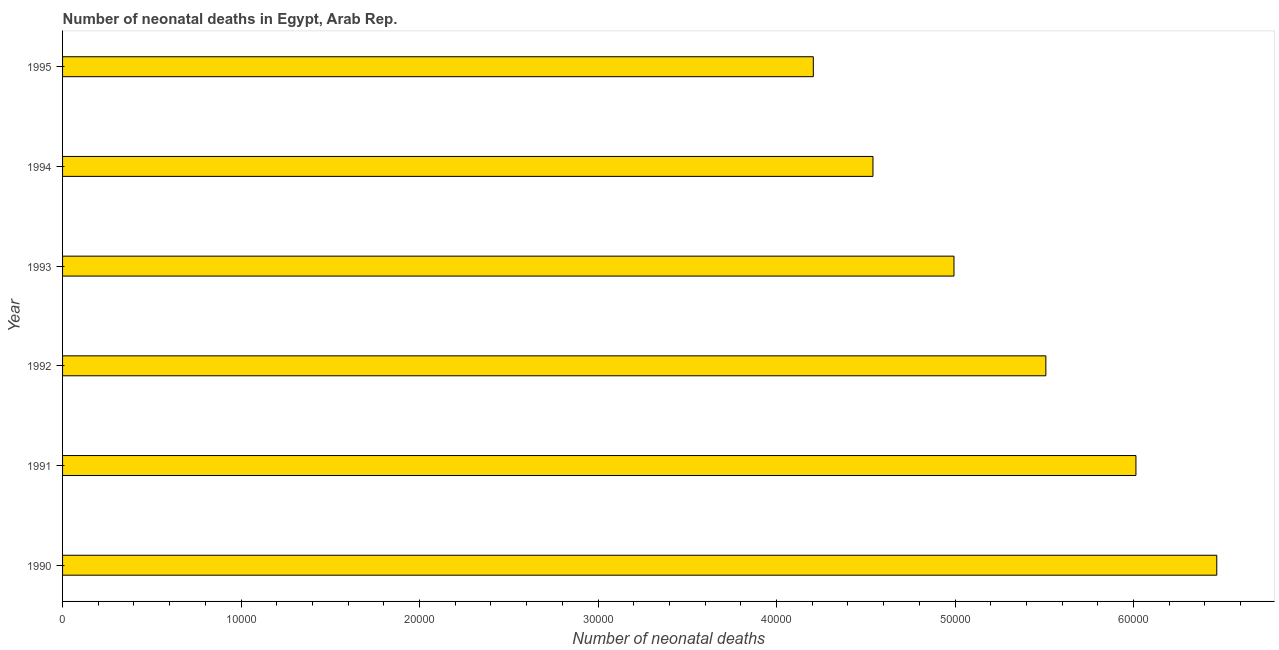Does the graph contain any zero values?
Keep it short and to the point. No. What is the title of the graph?
Offer a very short reply. Number of neonatal deaths in Egypt, Arab Rep. What is the label or title of the X-axis?
Provide a succinct answer. Number of neonatal deaths. What is the number of neonatal deaths in 1991?
Offer a terse response. 6.01e+04. Across all years, what is the maximum number of neonatal deaths?
Provide a succinct answer. 6.47e+04. Across all years, what is the minimum number of neonatal deaths?
Your answer should be very brief. 4.21e+04. What is the sum of the number of neonatal deaths?
Your response must be concise. 3.17e+05. What is the difference between the number of neonatal deaths in 1991 and 1992?
Keep it short and to the point. 5047. What is the average number of neonatal deaths per year?
Keep it short and to the point. 5.29e+04. What is the median number of neonatal deaths?
Make the answer very short. 5.25e+04. In how many years, is the number of neonatal deaths greater than 38000 ?
Provide a succinct answer. 6. What is the ratio of the number of neonatal deaths in 1992 to that in 1994?
Make the answer very short. 1.21. Is the number of neonatal deaths in 1991 less than that in 1994?
Provide a succinct answer. No. Is the difference between the number of neonatal deaths in 1993 and 1995 greater than the difference between any two years?
Offer a very short reply. No. What is the difference between the highest and the second highest number of neonatal deaths?
Ensure brevity in your answer.  4529. What is the difference between the highest and the lowest number of neonatal deaths?
Your response must be concise. 2.26e+04. In how many years, is the number of neonatal deaths greater than the average number of neonatal deaths taken over all years?
Ensure brevity in your answer.  3. How many bars are there?
Ensure brevity in your answer.  6. Are all the bars in the graph horizontal?
Your answer should be very brief. Yes. What is the difference between two consecutive major ticks on the X-axis?
Provide a short and direct response. 10000. What is the Number of neonatal deaths in 1990?
Offer a very short reply. 6.47e+04. What is the Number of neonatal deaths of 1991?
Make the answer very short. 6.01e+04. What is the Number of neonatal deaths in 1992?
Offer a very short reply. 5.51e+04. What is the Number of neonatal deaths in 1993?
Keep it short and to the point. 4.99e+04. What is the Number of neonatal deaths in 1994?
Your answer should be compact. 4.54e+04. What is the Number of neonatal deaths of 1995?
Your answer should be very brief. 4.21e+04. What is the difference between the Number of neonatal deaths in 1990 and 1991?
Your answer should be very brief. 4529. What is the difference between the Number of neonatal deaths in 1990 and 1992?
Ensure brevity in your answer.  9576. What is the difference between the Number of neonatal deaths in 1990 and 1993?
Offer a very short reply. 1.47e+04. What is the difference between the Number of neonatal deaths in 1990 and 1994?
Provide a succinct answer. 1.93e+04. What is the difference between the Number of neonatal deaths in 1990 and 1995?
Your answer should be very brief. 2.26e+04. What is the difference between the Number of neonatal deaths in 1991 and 1992?
Provide a succinct answer. 5047. What is the difference between the Number of neonatal deaths in 1991 and 1993?
Provide a short and direct response. 1.02e+04. What is the difference between the Number of neonatal deaths in 1991 and 1994?
Your answer should be very brief. 1.47e+04. What is the difference between the Number of neonatal deaths in 1991 and 1995?
Give a very brief answer. 1.81e+04. What is the difference between the Number of neonatal deaths in 1992 and 1993?
Provide a short and direct response. 5147. What is the difference between the Number of neonatal deaths in 1992 and 1994?
Make the answer very short. 9686. What is the difference between the Number of neonatal deaths in 1992 and 1995?
Offer a terse response. 1.30e+04. What is the difference between the Number of neonatal deaths in 1993 and 1994?
Provide a short and direct response. 4539. What is the difference between the Number of neonatal deaths in 1993 and 1995?
Your answer should be very brief. 7881. What is the difference between the Number of neonatal deaths in 1994 and 1995?
Provide a succinct answer. 3342. What is the ratio of the Number of neonatal deaths in 1990 to that in 1991?
Your answer should be very brief. 1.07. What is the ratio of the Number of neonatal deaths in 1990 to that in 1992?
Your response must be concise. 1.17. What is the ratio of the Number of neonatal deaths in 1990 to that in 1993?
Make the answer very short. 1.29. What is the ratio of the Number of neonatal deaths in 1990 to that in 1994?
Keep it short and to the point. 1.42. What is the ratio of the Number of neonatal deaths in 1990 to that in 1995?
Offer a very short reply. 1.54. What is the ratio of the Number of neonatal deaths in 1991 to that in 1992?
Your answer should be very brief. 1.09. What is the ratio of the Number of neonatal deaths in 1991 to that in 1993?
Provide a succinct answer. 1.2. What is the ratio of the Number of neonatal deaths in 1991 to that in 1994?
Make the answer very short. 1.32. What is the ratio of the Number of neonatal deaths in 1991 to that in 1995?
Ensure brevity in your answer.  1.43. What is the ratio of the Number of neonatal deaths in 1992 to that in 1993?
Keep it short and to the point. 1.1. What is the ratio of the Number of neonatal deaths in 1992 to that in 1994?
Your response must be concise. 1.21. What is the ratio of the Number of neonatal deaths in 1992 to that in 1995?
Your answer should be compact. 1.31. What is the ratio of the Number of neonatal deaths in 1993 to that in 1995?
Keep it short and to the point. 1.19. What is the ratio of the Number of neonatal deaths in 1994 to that in 1995?
Offer a terse response. 1.08. 